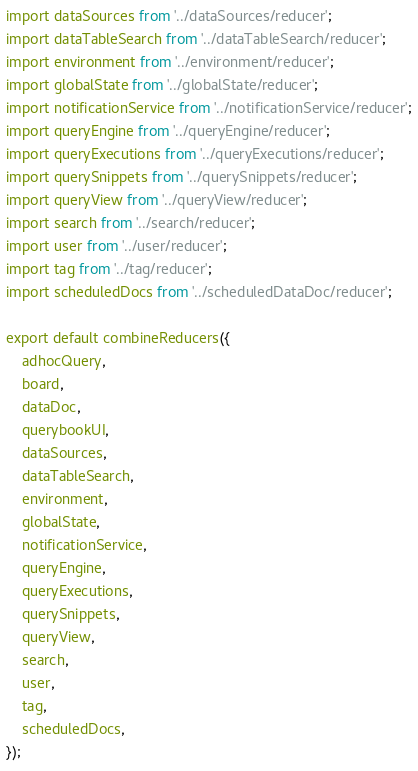<code> <loc_0><loc_0><loc_500><loc_500><_TypeScript_>import dataSources from '../dataSources/reducer';
import dataTableSearch from '../dataTableSearch/reducer';
import environment from '../environment/reducer';
import globalState from '../globalState/reducer';
import notificationService from '../notificationService/reducer';
import queryEngine from '../queryEngine/reducer';
import queryExecutions from '../queryExecutions/reducer';
import querySnippets from '../querySnippets/reducer';
import queryView from '../queryView/reducer';
import search from '../search/reducer';
import user from '../user/reducer';
import tag from '../tag/reducer';
import scheduledDocs from '../scheduledDataDoc/reducer';

export default combineReducers({
    adhocQuery,
    board,
    dataDoc,
    querybookUI,
    dataSources,
    dataTableSearch,
    environment,
    globalState,
    notificationService,
    queryEngine,
    queryExecutions,
    querySnippets,
    queryView,
    search,
    user,
    tag,
    scheduledDocs,
});
</code> 